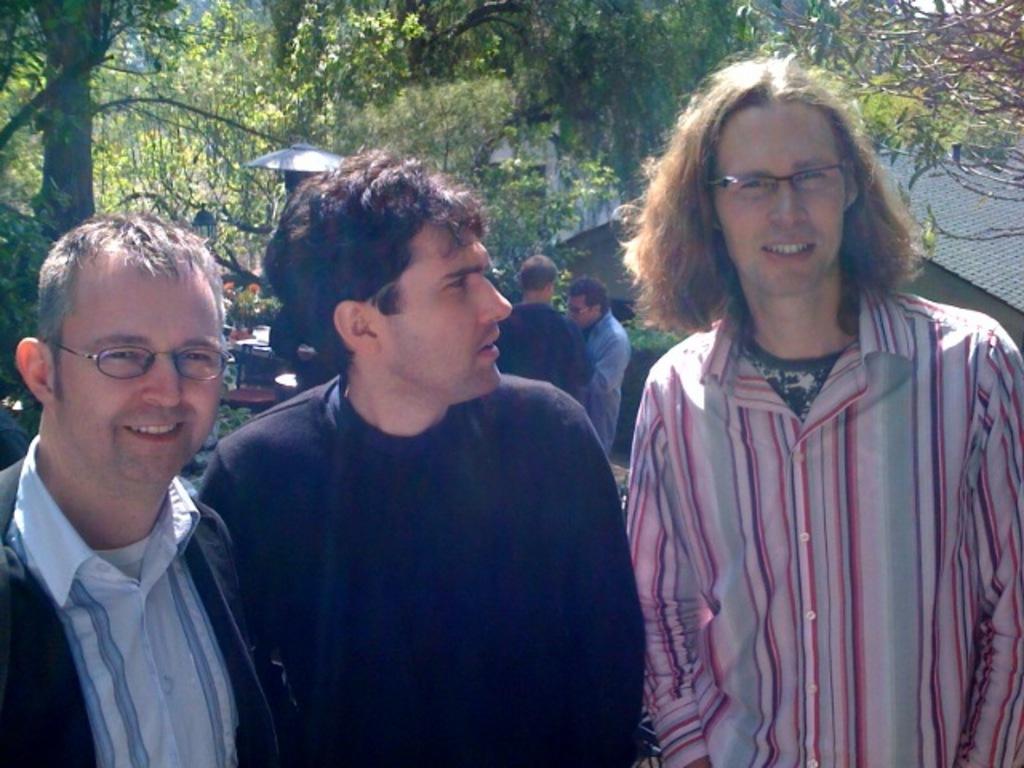How would you summarize this image in a sentence or two? In this image there are three persons standing, and in the background there is a house, table, chair, two persons standing, light, trees. 